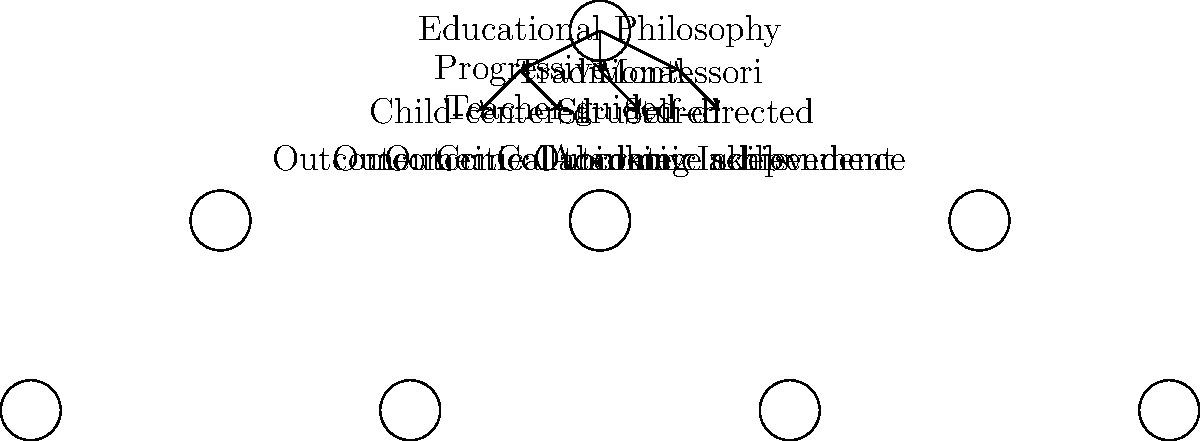Based on the decision tree diagram comparing various educational philosophies and their outcomes, which philosophy is most likely to foster independence in early childhood education? How might this align with or challenge your experiences at story hours? To answer this question, let's analyze the decision tree diagram step-by-step:

1. The diagram shows three main educational philosophies: Progressive, Traditional, and Montessori.

2. Each philosophy branches out to different approaches:
   - Progressive splits into Child-centered and Teacher-guided
   - Traditional leads to Structured
   - Montessori leads to Self-directed

3. The outcomes are listed at the bottom of the diagram:
   - Critical thinking (associated with Child-centered)
   - Collaborative skills (associated with Teacher-guided)
   - Academic achievement (associated with Structured)
   - Independence (associated with Self-directed)

4. The philosophy that directly leads to the "Self-directed" approach, which in turn results in "Independence" as an outcome, is the Montessori philosophy.

5. Montessori education is known for its emphasis on self-directed learning, where children are encouraged to make choices about their learning activities and work at their own pace. This approach naturally fosters independence in young learners.

6. Relating this to story hours:
   - Traditional story hours might be more structured, with a teacher or librarian leading the session.
   - However, some story hours may incorporate elements of self-directed learning, such as allowing children to choose books or participate in related activities independently.

7. The experience at story hours might align with this philosophy if:
   - Children are given choices in selecting books or activities.
   - The environment is prepared to allow for independent exploration.
   - Adults act more as guides rather than direct instructors.

8. It might challenge the experience if:
   - Story hours are highly structured with little room for individual choice.
   - All activities are adult-led with minimal opportunity for self-direction.

Understanding this can help in evaluating and potentially adapting story hour experiences to incorporate more elements that foster independence, aligning with the Montessori approach.
Answer: Montessori philosophy 